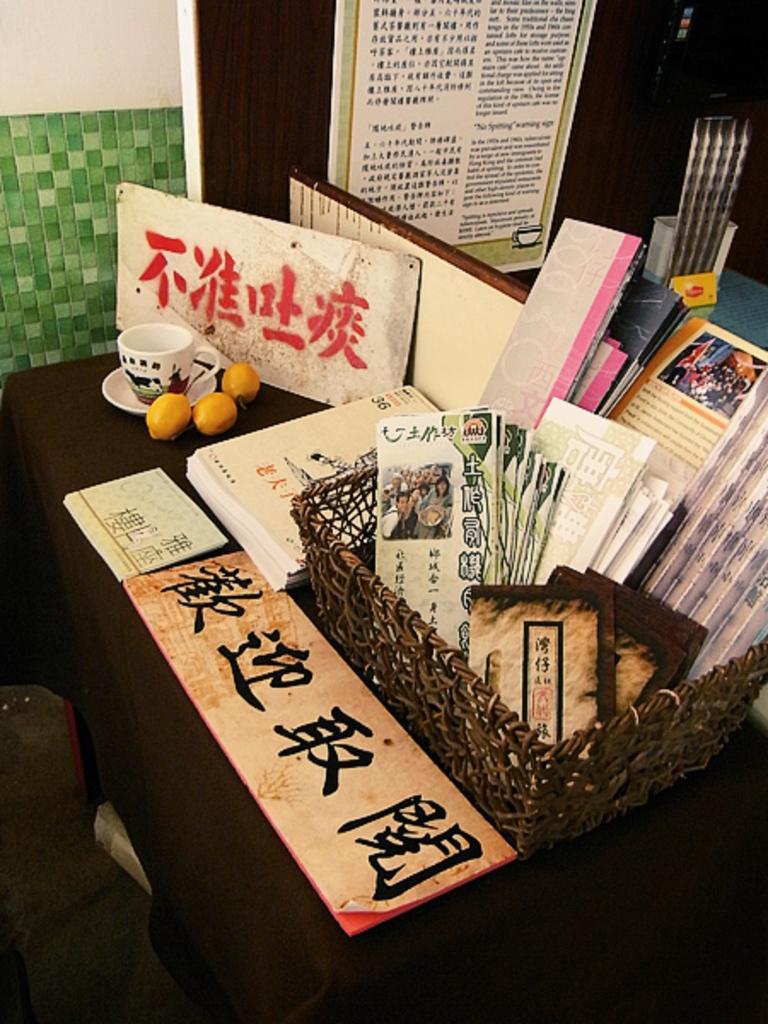In one or two sentences, can you explain what this image depicts? In the image we can see wooden basket. In the basket we can see there are books. Here we can see a cup, saucer, three oranges and a board. Here we can see the poster and the wall. 